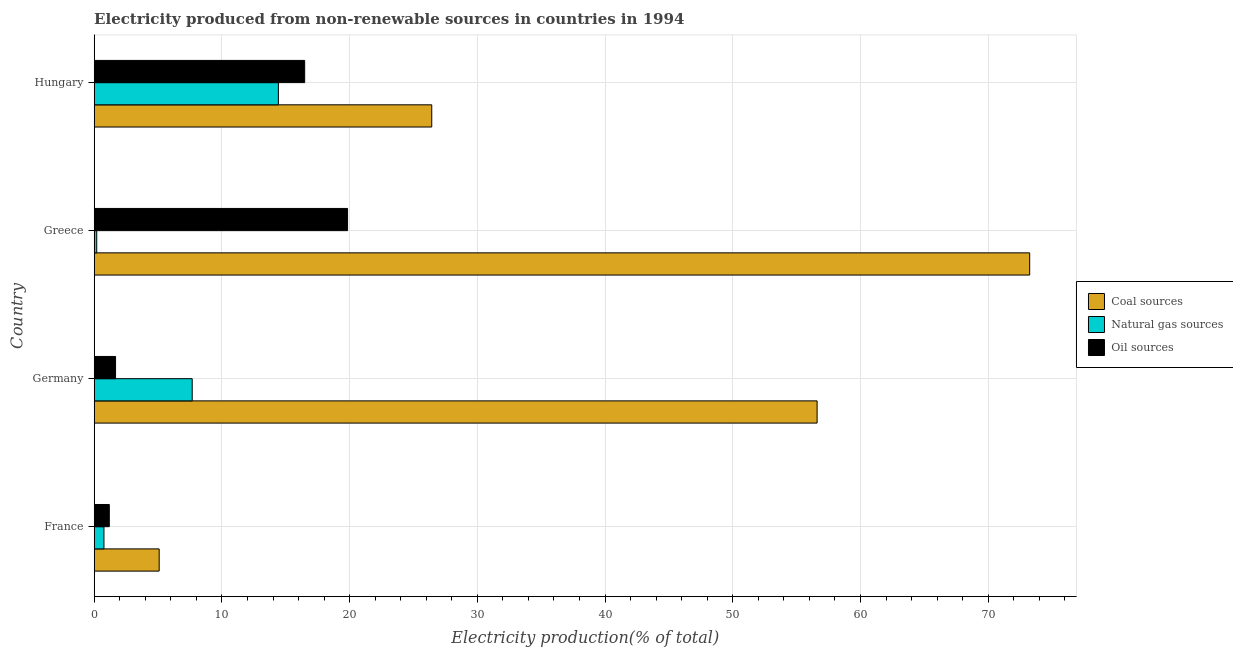How many different coloured bars are there?
Offer a terse response. 3. Are the number of bars on each tick of the Y-axis equal?
Your answer should be very brief. Yes. How many bars are there on the 4th tick from the bottom?
Offer a very short reply. 3. What is the percentage of electricity produced by coal in Germany?
Offer a terse response. 56.6. Across all countries, what is the maximum percentage of electricity produced by natural gas?
Offer a very short reply. 14.42. Across all countries, what is the minimum percentage of electricity produced by oil sources?
Provide a short and direct response. 1.18. In which country was the percentage of electricity produced by oil sources maximum?
Provide a short and direct response. Greece. In which country was the percentage of electricity produced by natural gas minimum?
Your answer should be very brief. Greece. What is the total percentage of electricity produced by natural gas in the graph?
Ensure brevity in your answer.  23.06. What is the difference between the percentage of electricity produced by natural gas in France and that in Germany?
Provide a short and direct response. -6.91. What is the difference between the percentage of electricity produced by natural gas in Hungary and the percentage of electricity produced by oil sources in Germany?
Provide a short and direct response. 12.75. What is the average percentage of electricity produced by coal per country?
Your answer should be very brief. 40.34. What is the difference between the percentage of electricity produced by oil sources and percentage of electricity produced by natural gas in Hungary?
Your answer should be compact. 2.06. In how many countries, is the percentage of electricity produced by coal greater than 50 %?
Your response must be concise. 2. What is the ratio of the percentage of electricity produced by coal in Germany to that in Greece?
Your answer should be very brief. 0.77. Is the difference between the percentage of electricity produced by coal in France and Hungary greater than the difference between the percentage of electricity produced by oil sources in France and Hungary?
Offer a very short reply. No. What is the difference between the highest and the second highest percentage of electricity produced by oil sources?
Your response must be concise. 3.36. What is the difference between the highest and the lowest percentage of electricity produced by coal?
Your response must be concise. 68.16. In how many countries, is the percentage of electricity produced by oil sources greater than the average percentage of electricity produced by oil sources taken over all countries?
Offer a very short reply. 2. What does the 3rd bar from the top in France represents?
Provide a short and direct response. Coal sources. What does the 2nd bar from the bottom in Greece represents?
Your answer should be compact. Natural gas sources. Is it the case that in every country, the sum of the percentage of electricity produced by coal and percentage of electricity produced by natural gas is greater than the percentage of electricity produced by oil sources?
Offer a terse response. Yes. Are all the bars in the graph horizontal?
Provide a short and direct response. Yes. How many countries are there in the graph?
Your answer should be very brief. 4. What is the difference between two consecutive major ticks on the X-axis?
Keep it short and to the point. 10. Are the values on the major ticks of X-axis written in scientific E-notation?
Ensure brevity in your answer.  No. Does the graph contain any zero values?
Your answer should be compact. No. Does the graph contain grids?
Your answer should be very brief. Yes. How many legend labels are there?
Provide a short and direct response. 3. What is the title of the graph?
Make the answer very short. Electricity produced from non-renewable sources in countries in 1994. What is the Electricity production(% of total) in Coal sources in France?
Ensure brevity in your answer.  5.09. What is the Electricity production(% of total) in Natural gas sources in France?
Your answer should be very brief. 0.76. What is the Electricity production(% of total) of Oil sources in France?
Your answer should be very brief. 1.18. What is the Electricity production(% of total) of Coal sources in Germany?
Offer a very short reply. 56.6. What is the Electricity production(% of total) of Natural gas sources in Germany?
Give a very brief answer. 7.67. What is the Electricity production(% of total) of Oil sources in Germany?
Provide a short and direct response. 1.67. What is the Electricity production(% of total) in Coal sources in Greece?
Make the answer very short. 73.25. What is the Electricity production(% of total) in Natural gas sources in Greece?
Give a very brief answer. 0.2. What is the Electricity production(% of total) in Oil sources in Greece?
Ensure brevity in your answer.  19.84. What is the Electricity production(% of total) of Coal sources in Hungary?
Your response must be concise. 26.43. What is the Electricity production(% of total) of Natural gas sources in Hungary?
Your answer should be very brief. 14.42. What is the Electricity production(% of total) of Oil sources in Hungary?
Your answer should be very brief. 16.48. Across all countries, what is the maximum Electricity production(% of total) in Coal sources?
Keep it short and to the point. 73.25. Across all countries, what is the maximum Electricity production(% of total) of Natural gas sources?
Offer a terse response. 14.42. Across all countries, what is the maximum Electricity production(% of total) in Oil sources?
Provide a short and direct response. 19.84. Across all countries, what is the minimum Electricity production(% of total) of Coal sources?
Provide a short and direct response. 5.09. Across all countries, what is the minimum Electricity production(% of total) of Natural gas sources?
Make the answer very short. 0.2. Across all countries, what is the minimum Electricity production(% of total) in Oil sources?
Give a very brief answer. 1.18. What is the total Electricity production(% of total) of Coal sources in the graph?
Ensure brevity in your answer.  161.37. What is the total Electricity production(% of total) of Natural gas sources in the graph?
Give a very brief answer. 23.06. What is the total Electricity production(% of total) in Oil sources in the graph?
Your answer should be compact. 39.17. What is the difference between the Electricity production(% of total) of Coal sources in France and that in Germany?
Offer a very short reply. -51.52. What is the difference between the Electricity production(% of total) of Natural gas sources in France and that in Germany?
Offer a terse response. -6.91. What is the difference between the Electricity production(% of total) of Oil sources in France and that in Germany?
Offer a very short reply. -0.49. What is the difference between the Electricity production(% of total) of Coal sources in France and that in Greece?
Your answer should be very brief. -68.16. What is the difference between the Electricity production(% of total) in Natural gas sources in France and that in Greece?
Provide a succinct answer. 0.57. What is the difference between the Electricity production(% of total) of Oil sources in France and that in Greece?
Provide a succinct answer. -18.66. What is the difference between the Electricity production(% of total) in Coal sources in France and that in Hungary?
Provide a succinct answer. -21.34. What is the difference between the Electricity production(% of total) of Natural gas sources in France and that in Hungary?
Your answer should be compact. -13.66. What is the difference between the Electricity production(% of total) of Oil sources in France and that in Hungary?
Make the answer very short. -15.3. What is the difference between the Electricity production(% of total) in Coal sources in Germany and that in Greece?
Ensure brevity in your answer.  -16.64. What is the difference between the Electricity production(% of total) in Natural gas sources in Germany and that in Greece?
Ensure brevity in your answer.  7.48. What is the difference between the Electricity production(% of total) in Oil sources in Germany and that in Greece?
Your answer should be compact. -18.17. What is the difference between the Electricity production(% of total) of Coal sources in Germany and that in Hungary?
Provide a succinct answer. 30.17. What is the difference between the Electricity production(% of total) in Natural gas sources in Germany and that in Hungary?
Ensure brevity in your answer.  -6.75. What is the difference between the Electricity production(% of total) in Oil sources in Germany and that in Hungary?
Your answer should be compact. -14.81. What is the difference between the Electricity production(% of total) of Coal sources in Greece and that in Hungary?
Your answer should be compact. 46.82. What is the difference between the Electricity production(% of total) of Natural gas sources in Greece and that in Hungary?
Offer a terse response. -14.23. What is the difference between the Electricity production(% of total) in Oil sources in Greece and that in Hungary?
Keep it short and to the point. 3.36. What is the difference between the Electricity production(% of total) in Coal sources in France and the Electricity production(% of total) in Natural gas sources in Germany?
Ensure brevity in your answer.  -2.59. What is the difference between the Electricity production(% of total) in Coal sources in France and the Electricity production(% of total) in Oil sources in Germany?
Make the answer very short. 3.41. What is the difference between the Electricity production(% of total) in Natural gas sources in France and the Electricity production(% of total) in Oil sources in Germany?
Provide a succinct answer. -0.91. What is the difference between the Electricity production(% of total) in Coal sources in France and the Electricity production(% of total) in Natural gas sources in Greece?
Keep it short and to the point. 4.89. What is the difference between the Electricity production(% of total) in Coal sources in France and the Electricity production(% of total) in Oil sources in Greece?
Offer a terse response. -14.75. What is the difference between the Electricity production(% of total) in Natural gas sources in France and the Electricity production(% of total) in Oil sources in Greece?
Provide a short and direct response. -19.07. What is the difference between the Electricity production(% of total) in Coal sources in France and the Electricity production(% of total) in Natural gas sources in Hungary?
Provide a succinct answer. -9.34. What is the difference between the Electricity production(% of total) in Coal sources in France and the Electricity production(% of total) in Oil sources in Hungary?
Ensure brevity in your answer.  -11.39. What is the difference between the Electricity production(% of total) of Natural gas sources in France and the Electricity production(% of total) of Oil sources in Hungary?
Your answer should be compact. -15.72. What is the difference between the Electricity production(% of total) in Coal sources in Germany and the Electricity production(% of total) in Natural gas sources in Greece?
Your answer should be very brief. 56.4. What is the difference between the Electricity production(% of total) of Coal sources in Germany and the Electricity production(% of total) of Oil sources in Greece?
Provide a short and direct response. 36.76. What is the difference between the Electricity production(% of total) in Natural gas sources in Germany and the Electricity production(% of total) in Oil sources in Greece?
Ensure brevity in your answer.  -12.16. What is the difference between the Electricity production(% of total) in Coal sources in Germany and the Electricity production(% of total) in Natural gas sources in Hungary?
Your answer should be very brief. 42.18. What is the difference between the Electricity production(% of total) in Coal sources in Germany and the Electricity production(% of total) in Oil sources in Hungary?
Ensure brevity in your answer.  40.12. What is the difference between the Electricity production(% of total) of Natural gas sources in Germany and the Electricity production(% of total) of Oil sources in Hungary?
Keep it short and to the point. -8.81. What is the difference between the Electricity production(% of total) in Coal sources in Greece and the Electricity production(% of total) in Natural gas sources in Hungary?
Your answer should be compact. 58.82. What is the difference between the Electricity production(% of total) of Coal sources in Greece and the Electricity production(% of total) of Oil sources in Hungary?
Provide a short and direct response. 56.77. What is the difference between the Electricity production(% of total) of Natural gas sources in Greece and the Electricity production(% of total) of Oil sources in Hungary?
Ensure brevity in your answer.  -16.28. What is the average Electricity production(% of total) in Coal sources per country?
Ensure brevity in your answer.  40.34. What is the average Electricity production(% of total) in Natural gas sources per country?
Make the answer very short. 5.76. What is the average Electricity production(% of total) in Oil sources per country?
Offer a very short reply. 9.79. What is the difference between the Electricity production(% of total) of Coal sources and Electricity production(% of total) of Natural gas sources in France?
Make the answer very short. 4.32. What is the difference between the Electricity production(% of total) in Coal sources and Electricity production(% of total) in Oil sources in France?
Offer a very short reply. 3.9. What is the difference between the Electricity production(% of total) of Natural gas sources and Electricity production(% of total) of Oil sources in France?
Provide a short and direct response. -0.42. What is the difference between the Electricity production(% of total) in Coal sources and Electricity production(% of total) in Natural gas sources in Germany?
Give a very brief answer. 48.93. What is the difference between the Electricity production(% of total) of Coal sources and Electricity production(% of total) of Oil sources in Germany?
Your answer should be compact. 54.93. What is the difference between the Electricity production(% of total) in Natural gas sources and Electricity production(% of total) in Oil sources in Germany?
Ensure brevity in your answer.  6. What is the difference between the Electricity production(% of total) of Coal sources and Electricity production(% of total) of Natural gas sources in Greece?
Your answer should be very brief. 73.05. What is the difference between the Electricity production(% of total) in Coal sources and Electricity production(% of total) in Oil sources in Greece?
Keep it short and to the point. 53.41. What is the difference between the Electricity production(% of total) in Natural gas sources and Electricity production(% of total) in Oil sources in Greece?
Make the answer very short. -19.64. What is the difference between the Electricity production(% of total) of Coal sources and Electricity production(% of total) of Natural gas sources in Hungary?
Your answer should be compact. 12.01. What is the difference between the Electricity production(% of total) of Coal sources and Electricity production(% of total) of Oil sources in Hungary?
Offer a terse response. 9.95. What is the difference between the Electricity production(% of total) in Natural gas sources and Electricity production(% of total) in Oil sources in Hungary?
Ensure brevity in your answer.  -2.06. What is the ratio of the Electricity production(% of total) of Coal sources in France to that in Germany?
Your answer should be compact. 0.09. What is the ratio of the Electricity production(% of total) in Natural gas sources in France to that in Germany?
Offer a terse response. 0.1. What is the ratio of the Electricity production(% of total) of Oil sources in France to that in Germany?
Your answer should be very brief. 0.71. What is the ratio of the Electricity production(% of total) of Coal sources in France to that in Greece?
Provide a short and direct response. 0.07. What is the ratio of the Electricity production(% of total) in Natural gas sources in France to that in Greece?
Ensure brevity in your answer.  3.86. What is the ratio of the Electricity production(% of total) of Oil sources in France to that in Greece?
Provide a short and direct response. 0.06. What is the ratio of the Electricity production(% of total) of Coal sources in France to that in Hungary?
Provide a short and direct response. 0.19. What is the ratio of the Electricity production(% of total) in Natural gas sources in France to that in Hungary?
Offer a terse response. 0.05. What is the ratio of the Electricity production(% of total) in Oil sources in France to that in Hungary?
Make the answer very short. 0.07. What is the ratio of the Electricity production(% of total) in Coal sources in Germany to that in Greece?
Your answer should be compact. 0.77. What is the ratio of the Electricity production(% of total) in Natural gas sources in Germany to that in Greece?
Make the answer very short. 38.74. What is the ratio of the Electricity production(% of total) of Oil sources in Germany to that in Greece?
Your response must be concise. 0.08. What is the ratio of the Electricity production(% of total) in Coal sources in Germany to that in Hungary?
Make the answer very short. 2.14. What is the ratio of the Electricity production(% of total) of Natural gas sources in Germany to that in Hungary?
Ensure brevity in your answer.  0.53. What is the ratio of the Electricity production(% of total) of Oil sources in Germany to that in Hungary?
Ensure brevity in your answer.  0.1. What is the ratio of the Electricity production(% of total) in Coal sources in Greece to that in Hungary?
Keep it short and to the point. 2.77. What is the ratio of the Electricity production(% of total) in Natural gas sources in Greece to that in Hungary?
Offer a terse response. 0.01. What is the ratio of the Electricity production(% of total) of Oil sources in Greece to that in Hungary?
Make the answer very short. 1.2. What is the difference between the highest and the second highest Electricity production(% of total) in Coal sources?
Your answer should be compact. 16.64. What is the difference between the highest and the second highest Electricity production(% of total) of Natural gas sources?
Offer a very short reply. 6.75. What is the difference between the highest and the second highest Electricity production(% of total) of Oil sources?
Keep it short and to the point. 3.36. What is the difference between the highest and the lowest Electricity production(% of total) in Coal sources?
Offer a terse response. 68.16. What is the difference between the highest and the lowest Electricity production(% of total) of Natural gas sources?
Provide a short and direct response. 14.23. What is the difference between the highest and the lowest Electricity production(% of total) of Oil sources?
Make the answer very short. 18.66. 